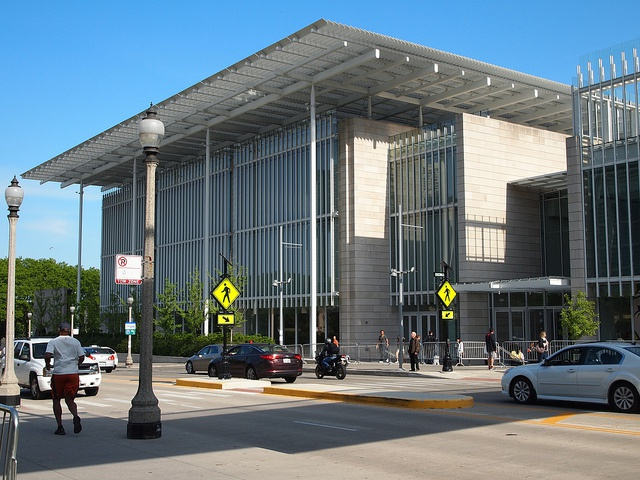Describe the objects in this image and their specific colors. I can see car in lightblue, black, gray, and darkblue tones, car in lightblue, black, white, gray, and darkgray tones, people in lightblue, black, darkgray, and gray tones, car in lightblue, black, gray, navy, and maroon tones, and car in lightblue, black, gray, navy, and blue tones in this image. 